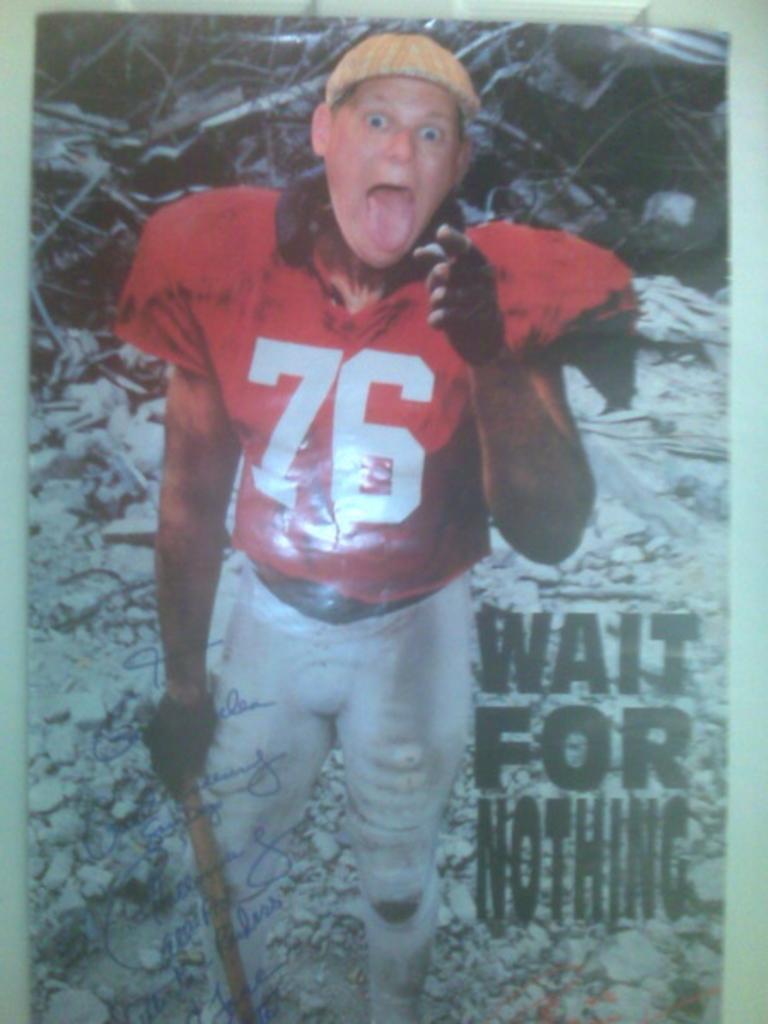Describe this image in one or two sentences. In this picture we can see a man standing on the icy ground and looking at someone. 